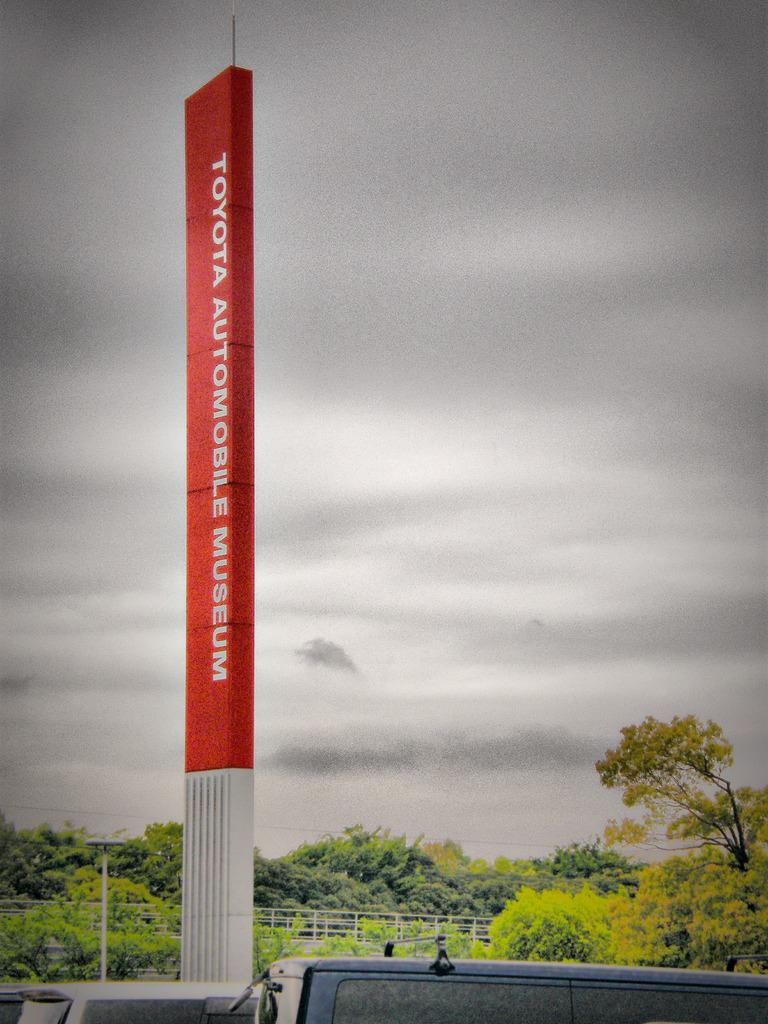What is the main structure in the image? There is a tower in the image. What is written or depicted on the tower? There is text on the tower. What type of vegetation can be seen in the image? There are trees in the image. What else is present in the image besides the tower and trees? Vehicles and a fence are present in the image. What can be seen in the background of the image? The sky with clouds is visible in the background of the image. How many legs does the tower have in the image? The tower is a structure and does not have legs; it stands on a foundation. What type of plot is the tower built on in the image? The tower is not built on a plot in the image; it is a standalone structure. 